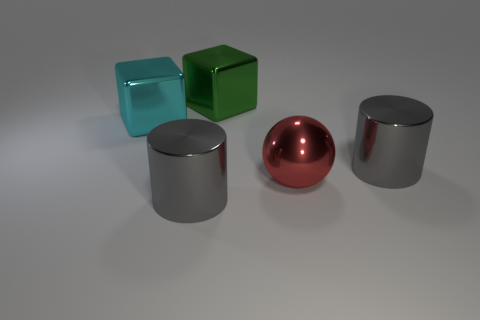There is a big thing that is both behind the large ball and left of the green metal object; what is it made of?
Keep it short and to the point. Metal. Is there a tiny yellow object?
Your response must be concise. No. Is there anything else that is the same shape as the large red thing?
Your answer should be compact. No. The green object that is behind the gray shiny thing left of the large object that is behind the big cyan metal thing is what shape?
Your answer should be very brief. Cube. The big cyan shiny thing is what shape?
Offer a terse response. Cube. There is a large sphere that is in front of the cyan block; what color is it?
Make the answer very short. Red. There is a green object that is the same shape as the cyan metal object; what size is it?
Provide a short and direct response. Large. Is the shape of the large green object the same as the large cyan metallic object?
Offer a very short reply. Yes. Are there fewer red shiny objects that are behind the red object than shiny cylinders on the right side of the green metal object?
Offer a terse response. Yes. There is a cyan thing; how many objects are behind it?
Provide a succinct answer. 1. 